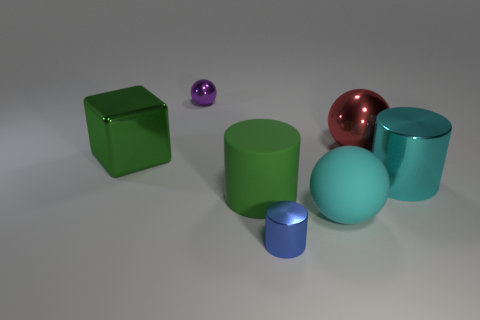Add 2 large red metal cubes. How many objects exist? 9 Subtract all balls. How many objects are left? 4 Add 2 big cyan rubber things. How many big cyan rubber things are left? 3 Add 4 small red blocks. How many small red blocks exist? 4 Subtract 0 yellow blocks. How many objects are left? 7 Subtract all large blue metal spheres. Subtract all big red metal balls. How many objects are left? 6 